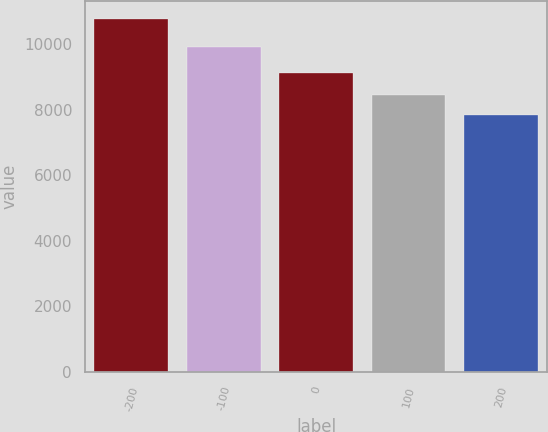<chart> <loc_0><loc_0><loc_500><loc_500><bar_chart><fcel>-200<fcel>-100<fcel>0<fcel>100<fcel>200<nl><fcel>10777<fcel>9901<fcel>9127<fcel>8439<fcel>7837<nl></chart> 